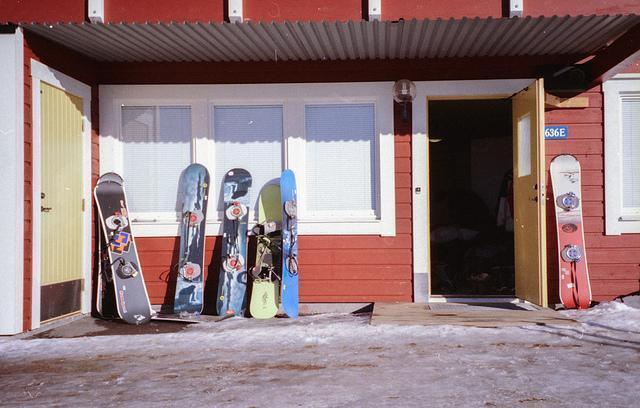What activity are the boards lined up against the building used for?
Answer the question by selecting the correct answer among the 4 following choices and explain your choice with a short sentence. The answer should be formatted with the following format: `Answer: choice
Rationale: rationale.`
Options: Football, skiing, soccer, snowboarding. Answer: snowboarding.
Rationale: These are used for snow. 